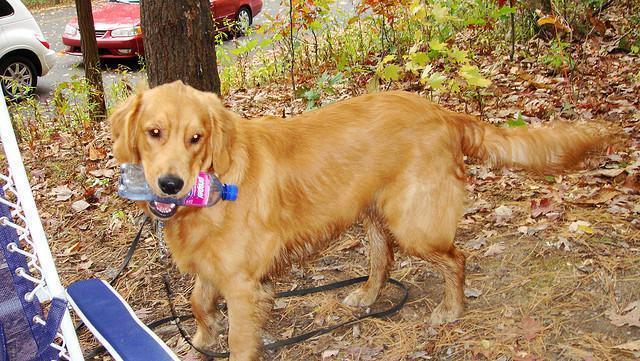How many cars are visible?
Give a very brief answer. 2. 